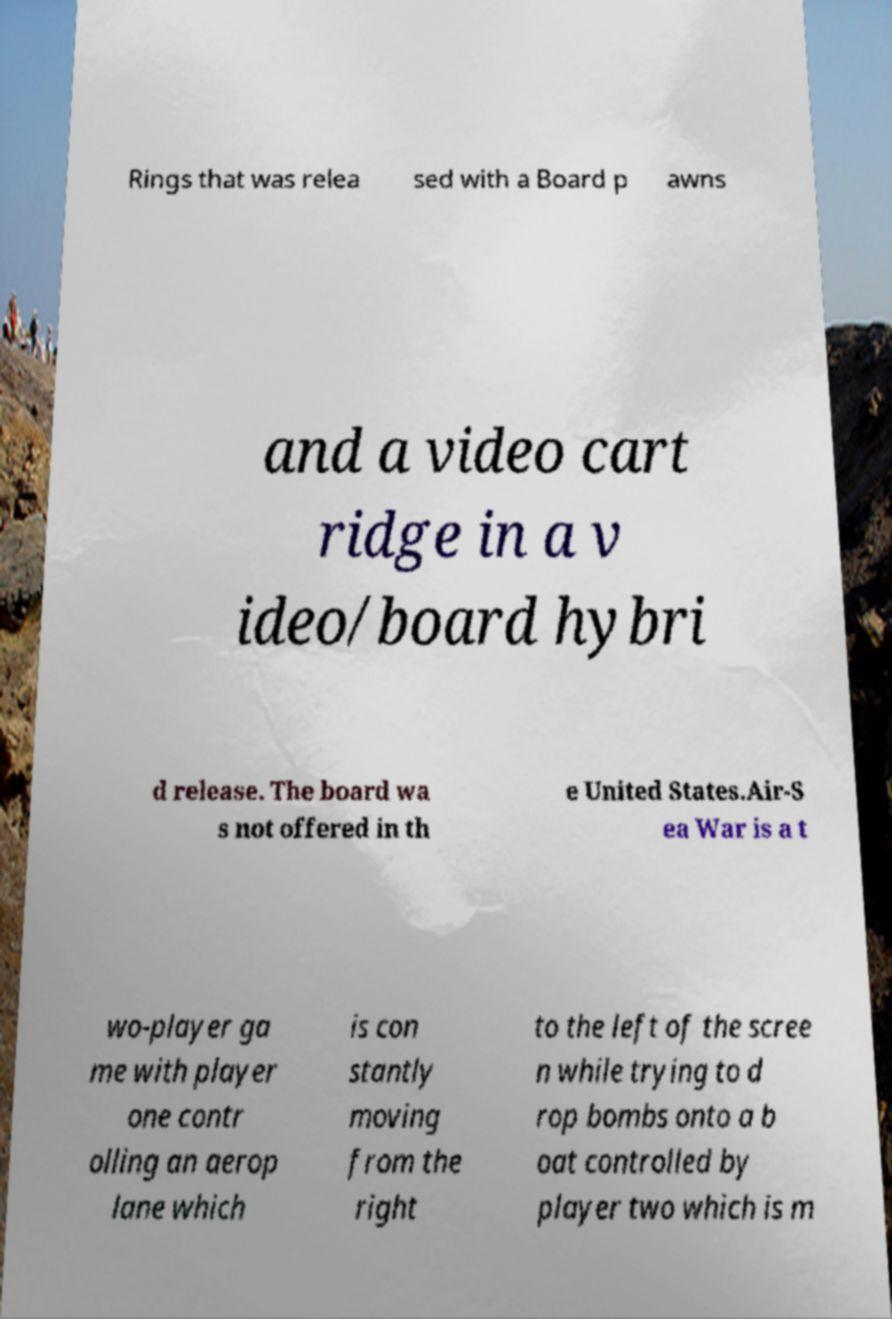For documentation purposes, I need the text within this image transcribed. Could you provide that? Rings that was relea sed with a Board p awns and a video cart ridge in a v ideo/board hybri d release. The board wa s not offered in th e United States.Air-S ea War is a t wo-player ga me with player one contr olling an aerop lane which is con stantly moving from the right to the left of the scree n while trying to d rop bombs onto a b oat controlled by player two which is m 